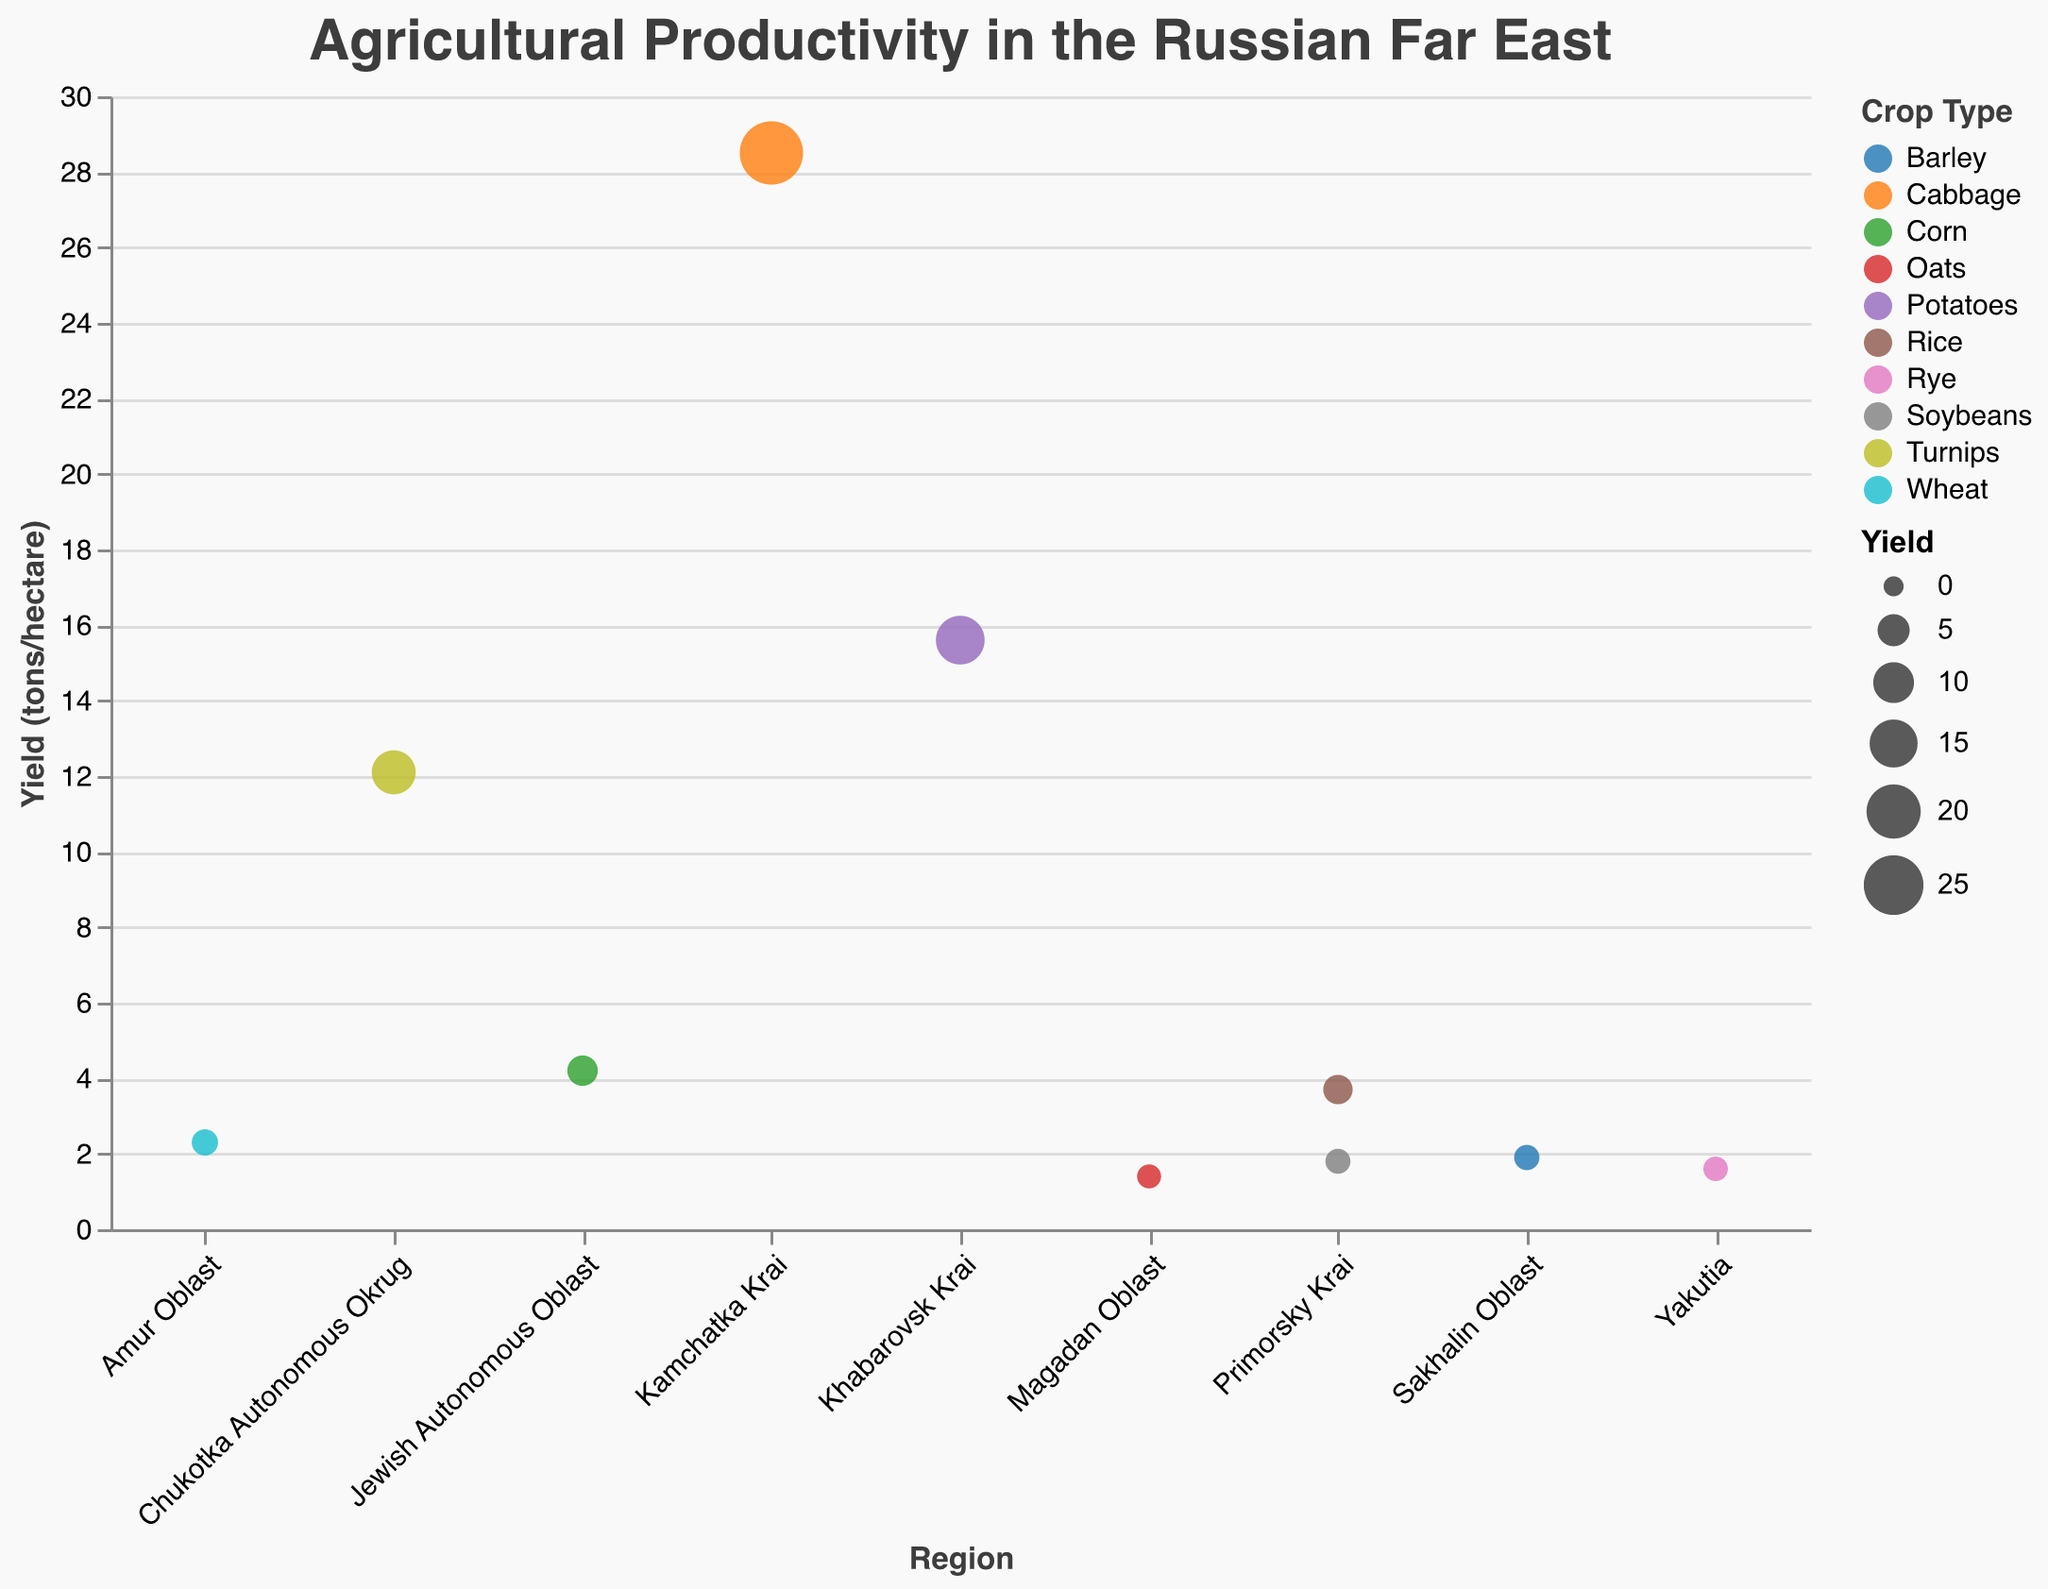What is the title of the plot? The title of the plot is displayed at the top, and it reads "Agricultural Productivity in the Russian Far East".
Answer: Agricultural Productivity in the Russian Far East Which region has the highest yield? The size of the circles indicates the yield, with larger circles representing higher yields. Kamchatka Krai, which produces cabbage, has the largest circle indicating the highest yield of 28.5 tons/hectare.
Answer: Kamchatka Krai What crop type is represented by the largest circle? The largest circle corresponds with Kamchatka Krai, which produces cabbage. This indicates that cabbage has the highest yield at 28.5 tons/hectare.
Answer: Cabbage How many regions are displayed in the plot? By counting the regions listed along the x-axis and the distinct colored circles, we see there are 9 regions displayed in the plot.
Answer: 9 Compare the yields of wheat in Amur Oblast and rice in Primorsky Krai. Which has a higher yield? Amur Oblast's yield for wheat is 2.3 tons/hectare. Primorsky Krai's yield for rice is 3.7 tons/hectare. Thus, rice in Primorsky Krai has a higher yield.
Answer: Rice in Primorsky Krai Which crop has the lowest yield and in which region is it grown? By examining the size of the circles, the smallest circle corresponds to oats in Magadan Oblast with a yield of 1.4 tons/hectare, the lowest yield in the dataset.
Answer: Oats in Magadan Oblast What is the combined yield of all crops in Primorsky Krai? Primorsky Krai has yields of 1.8 tons/hectare for soybeans and 3.7 tons/hectare for rice. Summing them gives 1.8 + 3.7 = 5.5 tons/hectare.
Answer: 5.5 tons/hectare What is the average yield of crops grown across all regions? Summing all yields (1.8 + 2.3 + 15.6 + 4.2 + 1.9 + 28.5 + 1.4 + 12.1 + 1.6 + 3.7) gives 73.1. There are 10 crops, so the average yield is 73.1/10 = 7.31 tons/hectare.
Answer: 7.31 tons/hectare Which region grows potatoes and what is its yield? By looking at the crop type associated with each region, Khabarovsk Krai is identified as growing potatoes with a yield of 15.6 tons/hectare.
Answer: Khabarovsk Krai, 15.6 tons/hectare Which crop type is grown in Sakhalin Oblast and what is its yield? Sakhalin Oblast is represented by barley, which yields 1.9 tons/hectare as indicated by the color and size of the circle corresponding to that region on the plot.
Answer: Barley, 1.9 tons/hectare 